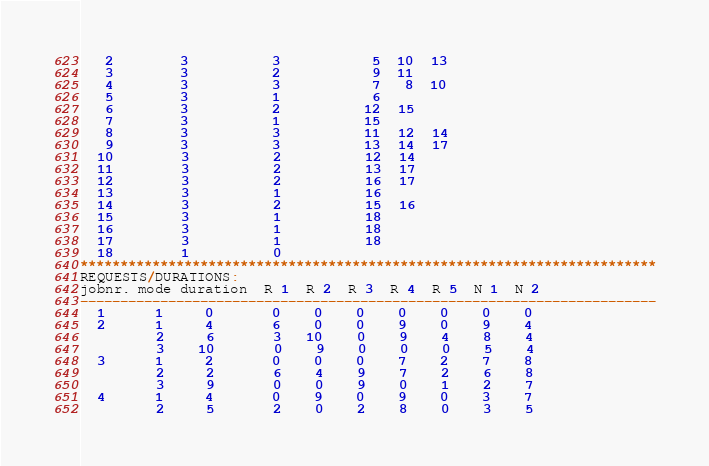<code> <loc_0><loc_0><loc_500><loc_500><_ObjectiveC_>   2        3          3           5  10  13
   3        3          2           9  11
   4        3          3           7   8  10
   5        3          1           6
   6        3          2          12  15
   7        3          1          15
   8        3          3          11  12  14
   9        3          3          13  14  17
  10        3          2          12  14
  11        3          2          13  17
  12        3          2          16  17
  13        3          1          16
  14        3          2          15  16
  15        3          1          18
  16        3          1          18
  17        3          1          18
  18        1          0        
************************************************************************
REQUESTS/DURATIONS:
jobnr. mode duration  R 1  R 2  R 3  R 4  R 5  N 1  N 2
------------------------------------------------------------------------
  1      1     0       0    0    0    0    0    0    0
  2      1     4       6    0    0    9    0    9    4
         2     6       3   10    0    9    4    8    4
         3    10       0    9    0    0    0    5    4
  3      1     2       0    0    0    7    2    7    8
         2     2       6    4    9    7    2    6    8
         3     9       0    0    9    0    1    2    7
  4      1     4       0    9    0    9    0    3    7
         2     5       2    0    2    8    0    3    5</code> 